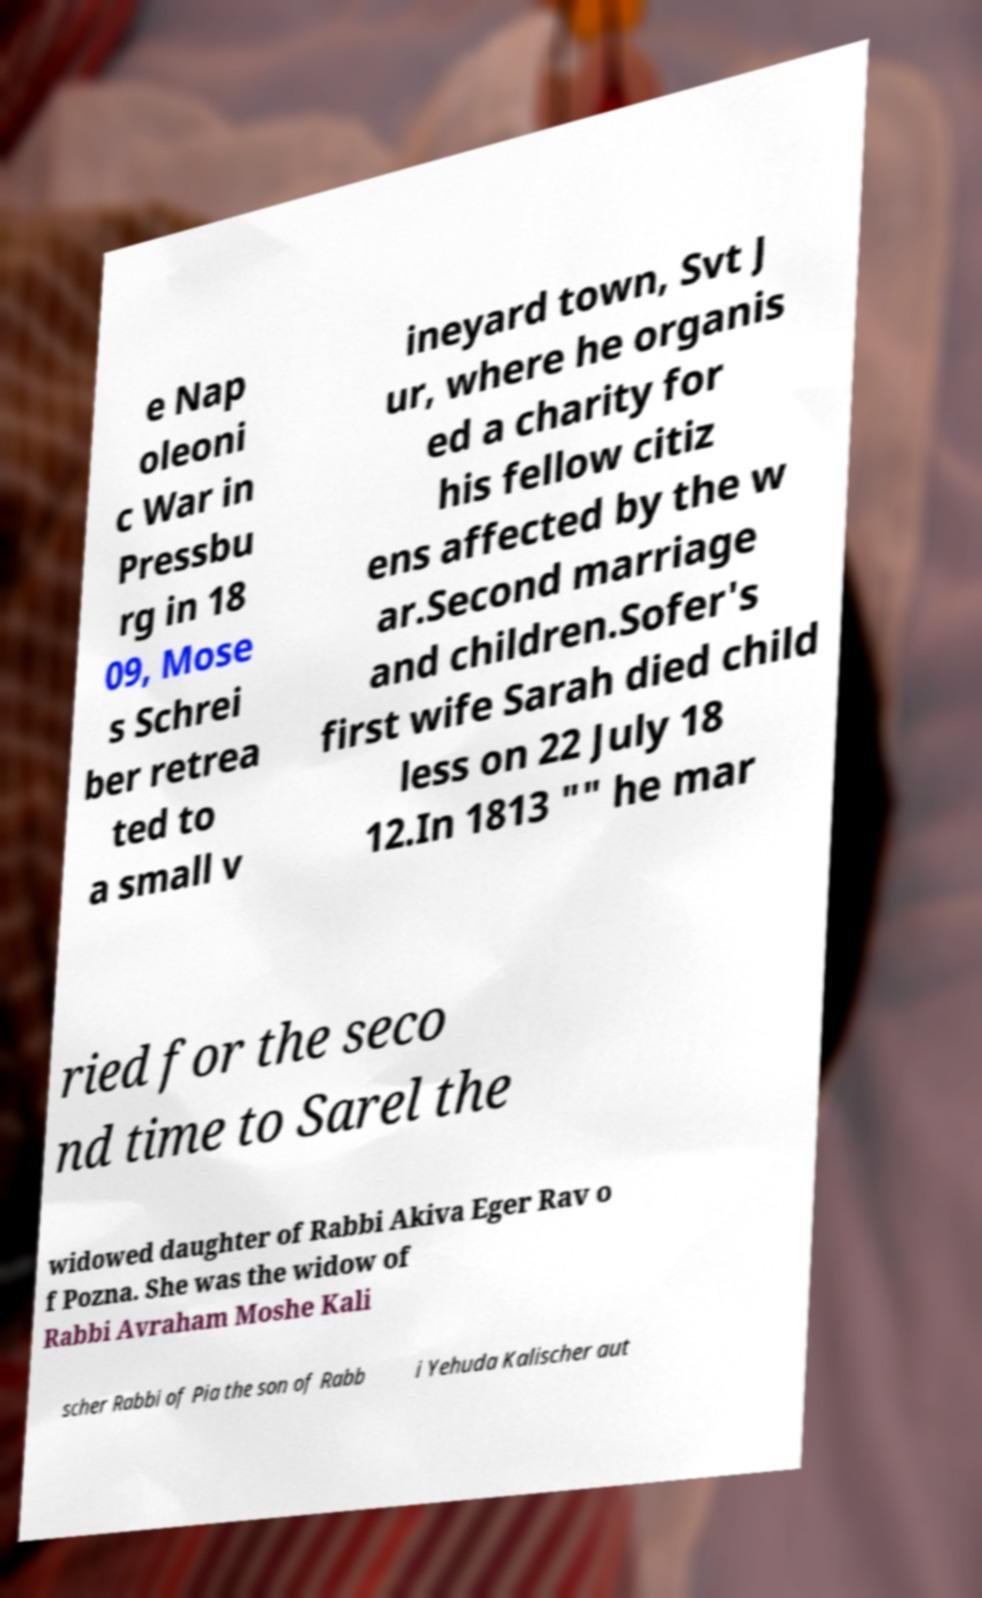I need the written content from this picture converted into text. Can you do that? e Nap oleoni c War in Pressbu rg in 18 09, Mose s Schrei ber retrea ted to a small v ineyard town, Svt J ur, where he organis ed a charity for his fellow citiz ens affected by the w ar.Second marriage and children.Sofer's first wife Sarah died child less on 22 July 18 12.In 1813 "" he mar ried for the seco nd time to Sarel the widowed daughter of Rabbi Akiva Eger Rav o f Pozna. She was the widow of Rabbi Avraham Moshe Kali scher Rabbi of Pia the son of Rabb i Yehuda Kalischer aut 